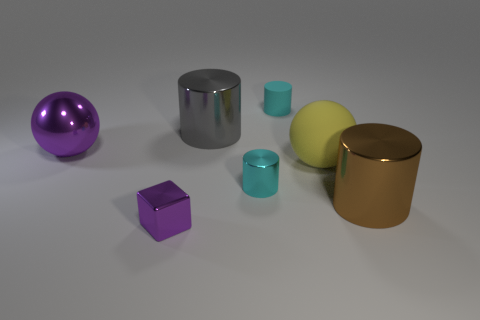Is there anything else that is the same shape as the small purple thing?
Make the answer very short. No. There is a cyan cylinder in front of the cyan rubber cylinder; how big is it?
Your answer should be very brief. Small. How many metallic cylinders are the same size as the metallic block?
Your answer should be compact. 1. Do the metal block and the cyan rubber cylinder behind the yellow object have the same size?
Offer a very short reply. Yes. How many things are cyan cylinders or large yellow objects?
Your answer should be compact. 3. How many metal cylinders have the same color as the block?
Ensure brevity in your answer.  0. There is a yellow object that is the same size as the brown cylinder; what shape is it?
Provide a short and direct response. Sphere. Is there another thing of the same shape as the yellow rubber object?
Make the answer very short. Yes. How many other big things have the same material as the large purple object?
Your answer should be compact. 2. Does the big sphere on the right side of the small purple block have the same material as the big gray cylinder?
Offer a terse response. No. 